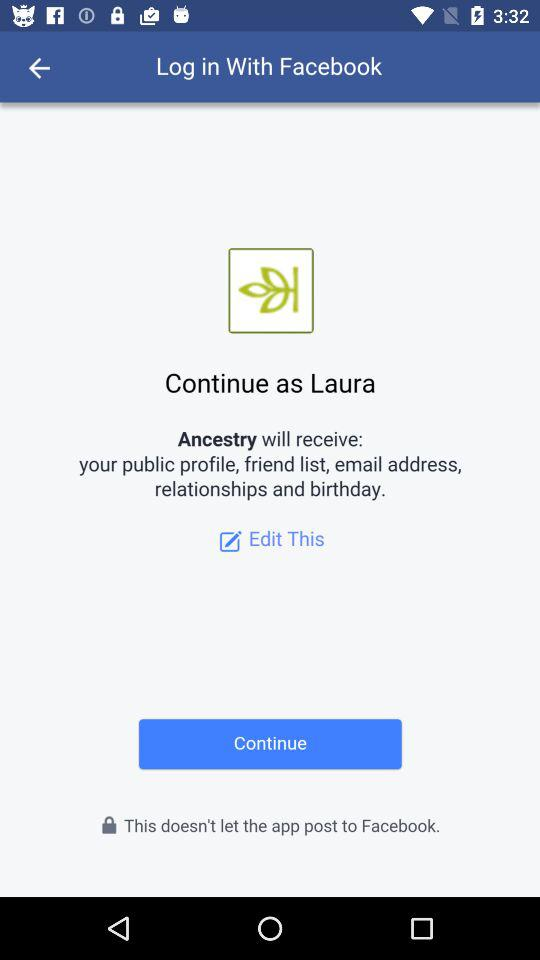What application will receive a public profile and email address? The application "Ancestry" will receive a public profile and email address. 